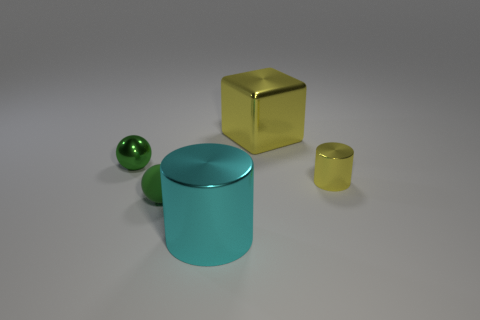There is a thing that is both to the right of the tiny rubber thing and in front of the small yellow metallic thing; what is its material?
Your answer should be compact. Metal. What number of objects are yellow metallic objects that are to the left of the yellow shiny cylinder or tiny metal objects?
Provide a succinct answer. 3. Is the big cube the same color as the big metal cylinder?
Provide a short and direct response. No. Is there a red matte cylinder of the same size as the metallic block?
Provide a short and direct response. No. What number of objects are to the right of the green matte thing and in front of the big yellow cube?
Give a very brief answer. 2. How many small balls are on the right side of the small yellow cylinder?
Provide a succinct answer. 0. Is there a small thing that has the same shape as the big cyan object?
Your answer should be very brief. Yes. There is a cyan shiny thing; is it the same shape as the yellow thing left of the tiny yellow thing?
Ensure brevity in your answer.  No. What number of spheres are tiny brown objects or yellow metallic things?
Your answer should be very brief. 0. What is the shape of the small green thing behind the tiny green rubber object?
Ensure brevity in your answer.  Sphere. 